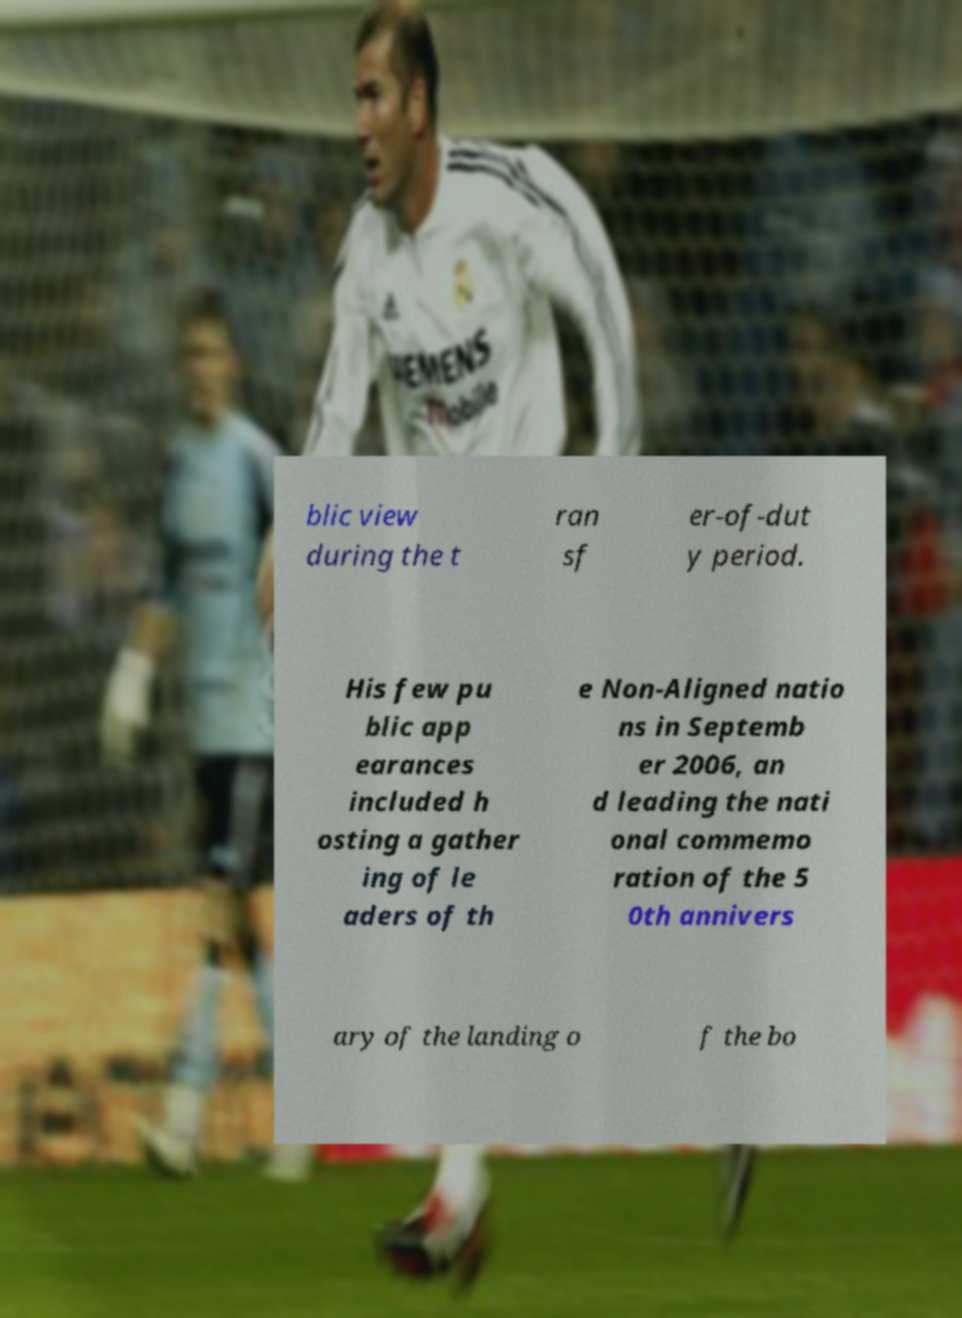What messages or text are displayed in this image? I need them in a readable, typed format. blic view during the t ran sf er-of-dut y period. His few pu blic app earances included h osting a gather ing of le aders of th e Non-Aligned natio ns in Septemb er 2006, an d leading the nati onal commemo ration of the 5 0th annivers ary of the landing o f the bo 